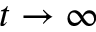<formula> <loc_0><loc_0><loc_500><loc_500>t \to \infty</formula> 